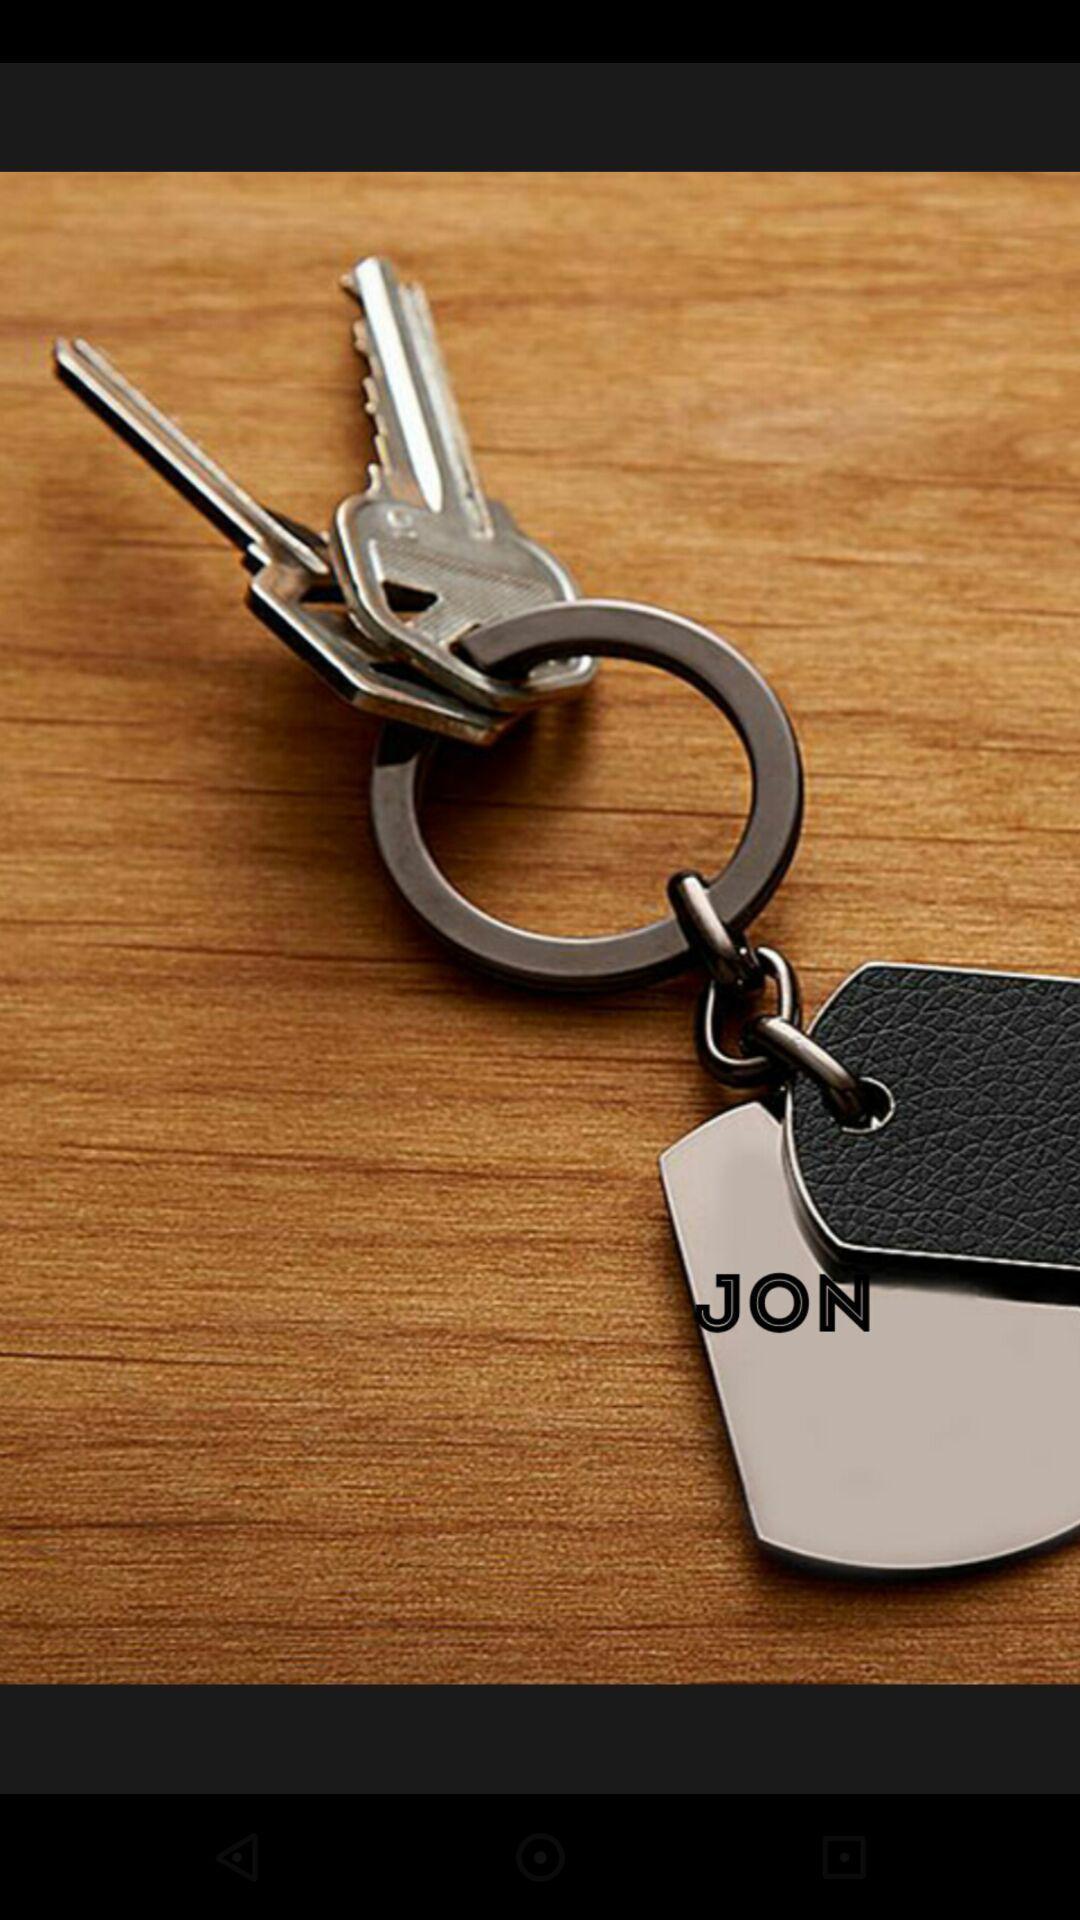Summarize the information in this screenshot. Page shows an image of key. 